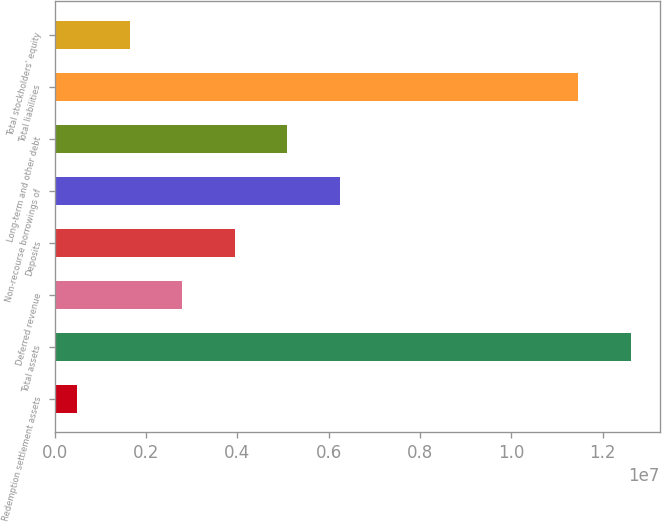Convert chart. <chart><loc_0><loc_0><loc_500><loc_500><bar_chart><fcel>Redemption settlement assets<fcel>Total assets<fcel>Deferred revenue<fcel>Deposits<fcel>Non-recourse borrowings of<fcel>Long-term and other debt<fcel>Total liabilities<fcel>Total stockholders' equity<nl><fcel>492690<fcel>1.26224e+07<fcel>2.79418e+06<fcel>3.94492e+06<fcel>6.24641e+06<fcel>5.09567e+06<fcel>1.14717e+07<fcel>1.64343e+06<nl></chart> 